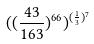<formula> <loc_0><loc_0><loc_500><loc_500>( ( \frac { 4 3 } { 1 6 3 } ) ^ { 6 6 } ) ^ { ( \frac { 1 } { 3 } ) ^ { 7 } }</formula> 